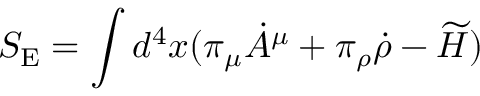Convert formula to latex. <formula><loc_0><loc_0><loc_500><loc_500>S _ { E } = \int d ^ { 4 } x ( \pi _ { \mu } \dot { A } ^ { \mu } + \pi _ { \rho } \dot { \rho } - \widetilde { H } )</formula> 